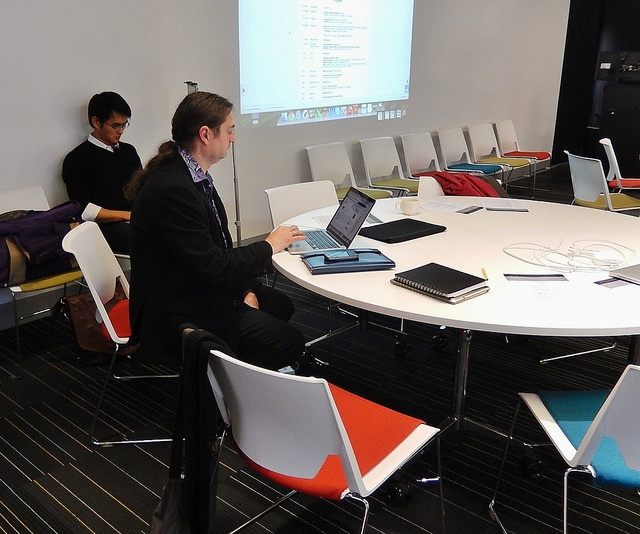Describe the objects in this image and their specific colors. I can see dining table in darkgray, white, black, and lightgray tones, people in darkgray, black, brown, and maroon tones, chair in darkgray, gray, black, and red tones, tv in darkgray, white, and lightblue tones, and chair in darkgray, black, and teal tones in this image. 